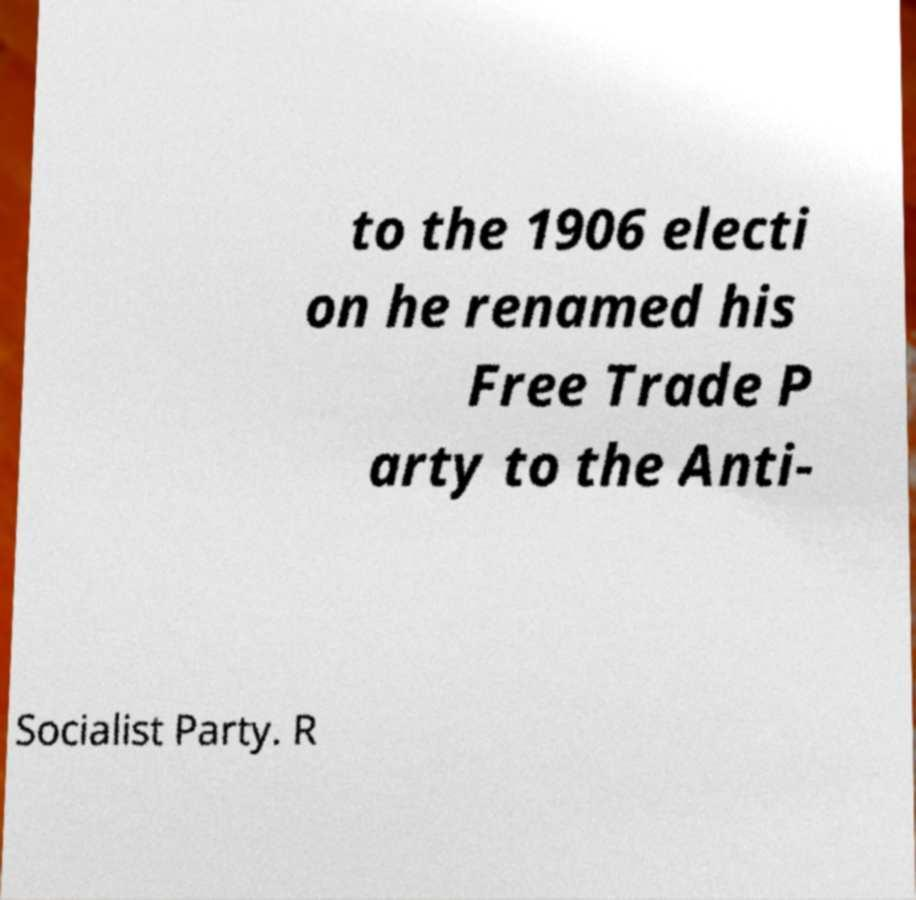Could you extract and type out the text from this image? to the 1906 electi on he renamed his Free Trade P arty to the Anti- Socialist Party. R 